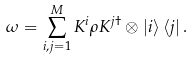Convert formula to latex. <formula><loc_0><loc_0><loc_500><loc_500>\omega = \sum _ { i , j = 1 } ^ { M } K ^ { i } \rho K ^ { j \dagger } \otimes \left | i \right \rangle \left \langle j \right | .</formula> 